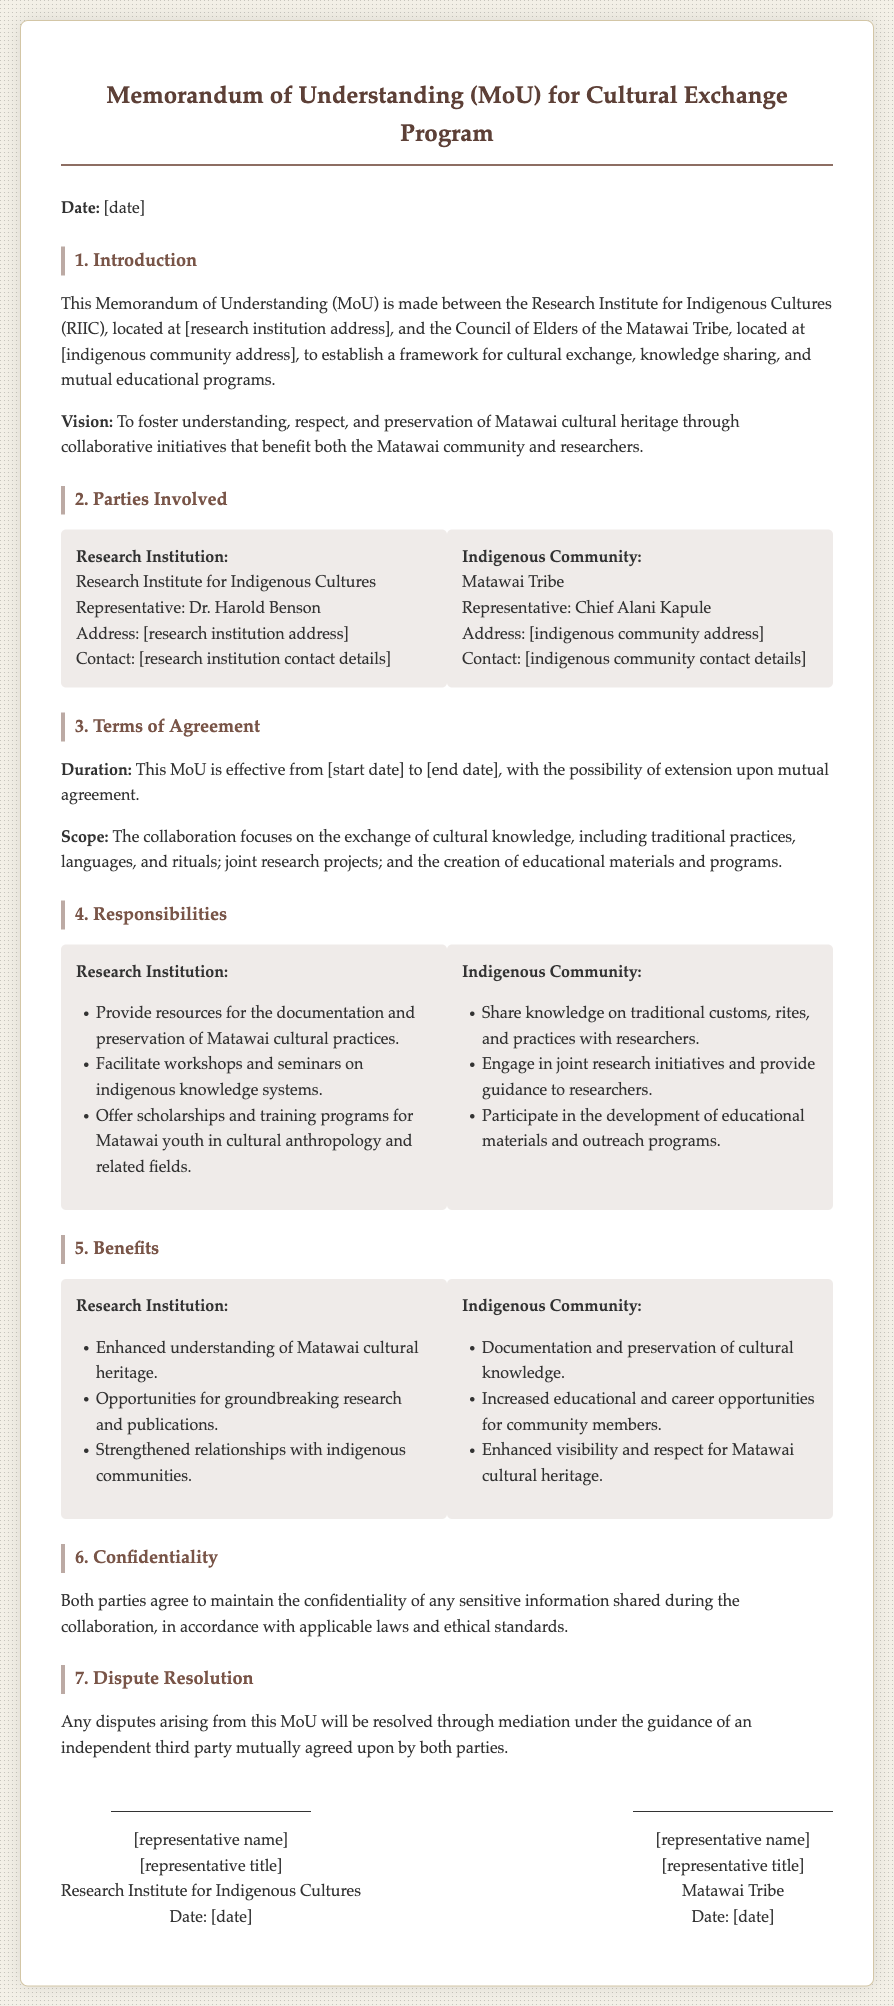What is the title of the document? The title of the document is stated prominently at the top, indicating its purpose.
Answer: Memorandum of Understanding (MoU) for Cultural Exchange Program Who represents the Research Institution? The name of the representative for the Research Institution is provided in the document.
Answer: Dr. Harold Benson What is the duration of the MoU? The document specifies a duration that can be referenced for effectiveness.
Answer: [start date] to [end date] What is the vision of the cultural exchange program? The vision statement in the document expresses the overarching goal of the agreement.
Answer: To foster understanding, respect, and preservation of Matawai cultural heritage What responsibilities does the indigenous community have? The document outlines specific responsibilities that are expected from the indigenous community.
Answer: Share knowledge on traditional customs, rites, and practices What is a benefit for the Research Institution? The document lists various benefits for the Research Institution involved in this MoU.
Answer: Enhanced understanding of Matawai cultural heritage What is the method for dispute resolution? The document mentions a specific approach for resolving disputes that may arise.
Answer: Mediation under the guidance of an independent third party What is included under the scope of this MoU? The scope section details what the collaboration will focus on through this MoU.
Answer: Exchange of cultural knowledge, including traditional practices, languages, and rituals 